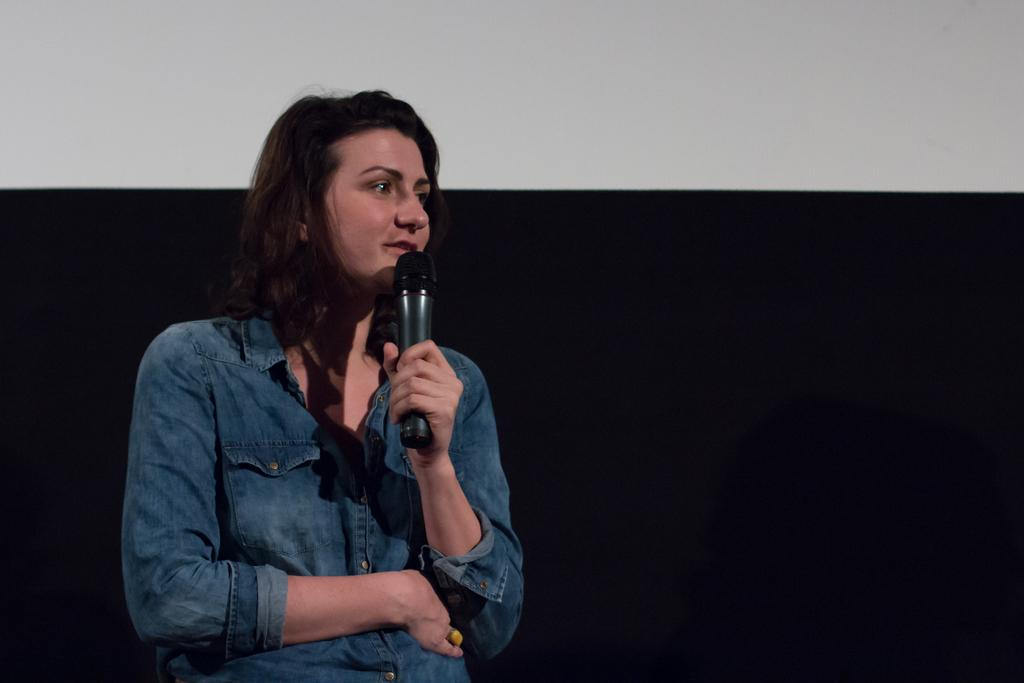Who is the main subject in the image? There is a woman in the image. What is the woman holding in her hand? The woman is holding a microphone in her hand. What is the woman wearing in the image? The woman is wearing a shirt. What color is the shirt the woman is wearing? The shirt is in blue color. Can you see a horse in the image? No, there is no horse present in the image. 